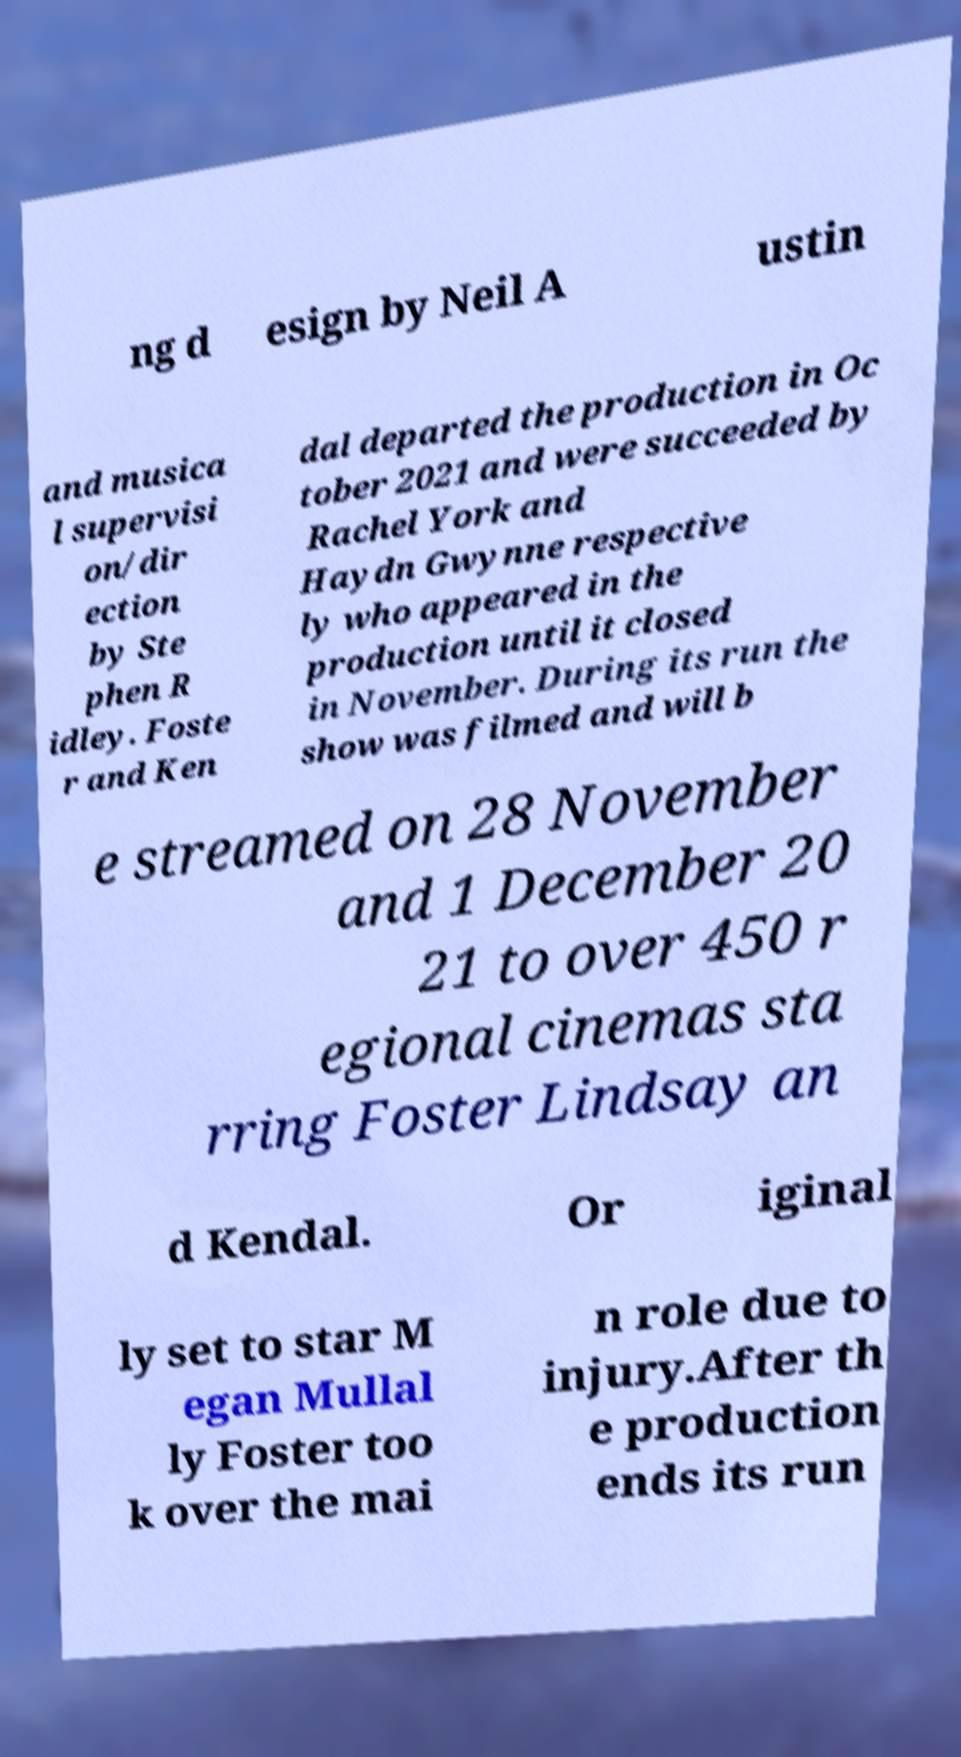There's text embedded in this image that I need extracted. Can you transcribe it verbatim? ng d esign by Neil A ustin and musica l supervisi on/dir ection by Ste phen R idley. Foste r and Ken dal departed the production in Oc tober 2021 and were succeeded by Rachel York and Haydn Gwynne respective ly who appeared in the production until it closed in November. During its run the show was filmed and will b e streamed on 28 November and 1 December 20 21 to over 450 r egional cinemas sta rring Foster Lindsay an d Kendal. Or iginal ly set to star M egan Mullal ly Foster too k over the mai n role due to injury.After th e production ends its run 